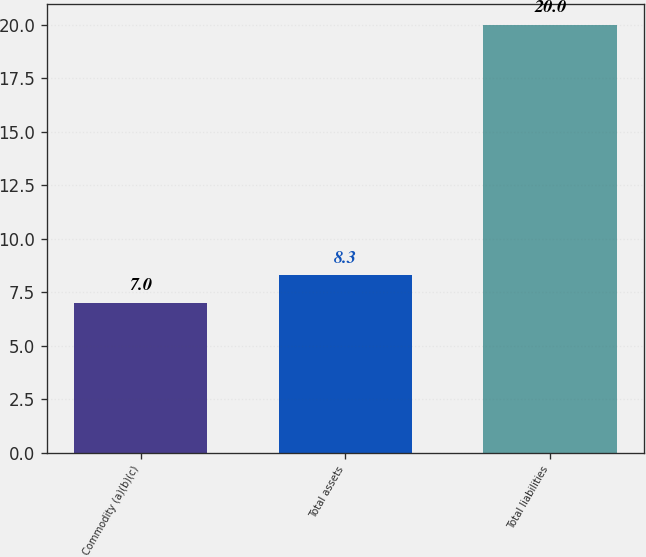Convert chart. <chart><loc_0><loc_0><loc_500><loc_500><bar_chart><fcel>Commodity (a)(b)(c)<fcel>Total assets<fcel>Total liabilities<nl><fcel>7<fcel>8.3<fcel>20<nl></chart> 